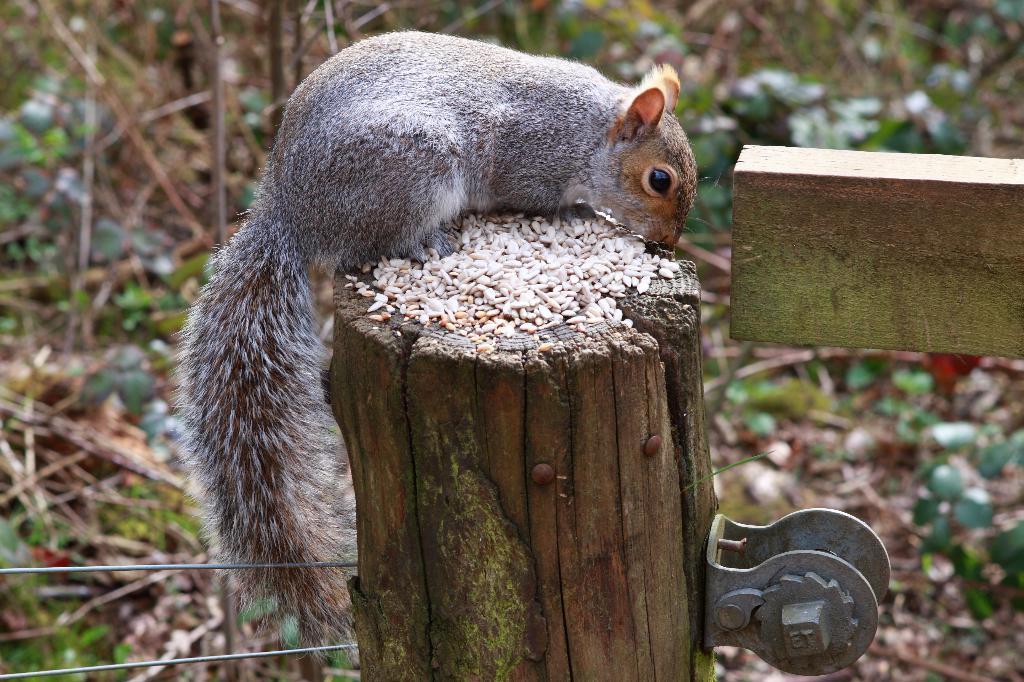Describe this image in one or two sentences. In this picture we can see a squirrel and wood in the front, in the background there are some leaves and plants. 